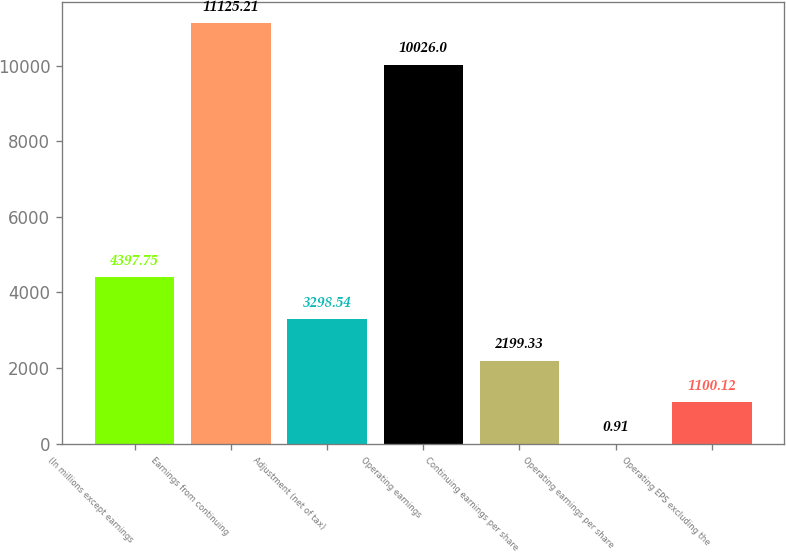Convert chart to OTSL. <chart><loc_0><loc_0><loc_500><loc_500><bar_chart><fcel>(In millions except earnings<fcel>Earnings from continuing<fcel>Adjustment (net of tax)<fcel>Operating earnings<fcel>Continuing earnings per share<fcel>Operating earnings per share<fcel>Operating EPS excluding the<nl><fcel>4397.75<fcel>11125.2<fcel>3298.54<fcel>10026<fcel>2199.33<fcel>0.91<fcel>1100.12<nl></chart> 